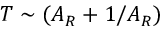Convert formula to latex. <formula><loc_0><loc_0><loc_500><loc_500>T \sim ( A _ { R } + 1 / A _ { R } )</formula> 